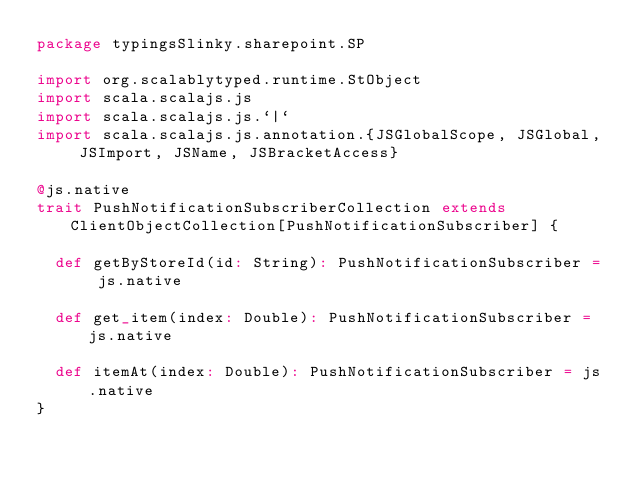Convert code to text. <code><loc_0><loc_0><loc_500><loc_500><_Scala_>package typingsSlinky.sharepoint.SP

import org.scalablytyped.runtime.StObject
import scala.scalajs.js
import scala.scalajs.js.`|`
import scala.scalajs.js.annotation.{JSGlobalScope, JSGlobal, JSImport, JSName, JSBracketAccess}

@js.native
trait PushNotificationSubscriberCollection extends ClientObjectCollection[PushNotificationSubscriber] {
  
  def getByStoreId(id: String): PushNotificationSubscriber = js.native
  
  def get_item(index: Double): PushNotificationSubscriber = js.native
  
  def itemAt(index: Double): PushNotificationSubscriber = js.native
}
</code> 